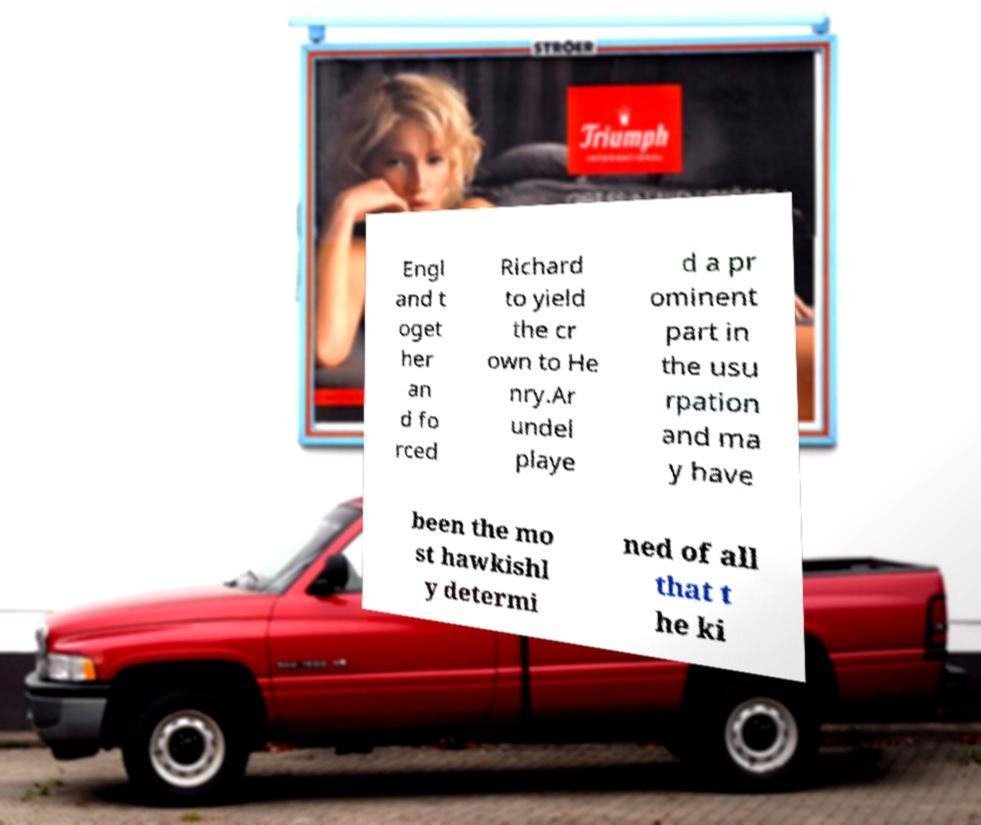I need the written content from this picture converted into text. Can you do that? Engl and t oget her an d fo rced Richard to yield the cr own to He nry.Ar undel playe d a pr ominent part in the usu rpation and ma y have been the mo st hawkishl y determi ned of all that t he ki 